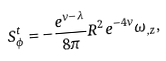Convert formula to latex. <formula><loc_0><loc_0><loc_500><loc_500>S ^ { t } _ { \phi } = - \frac { e ^ { \nu - \lambda } } { 8 \pi } { R } ^ { 2 } e ^ { - 4 \nu } \omega _ { , z } ,</formula> 